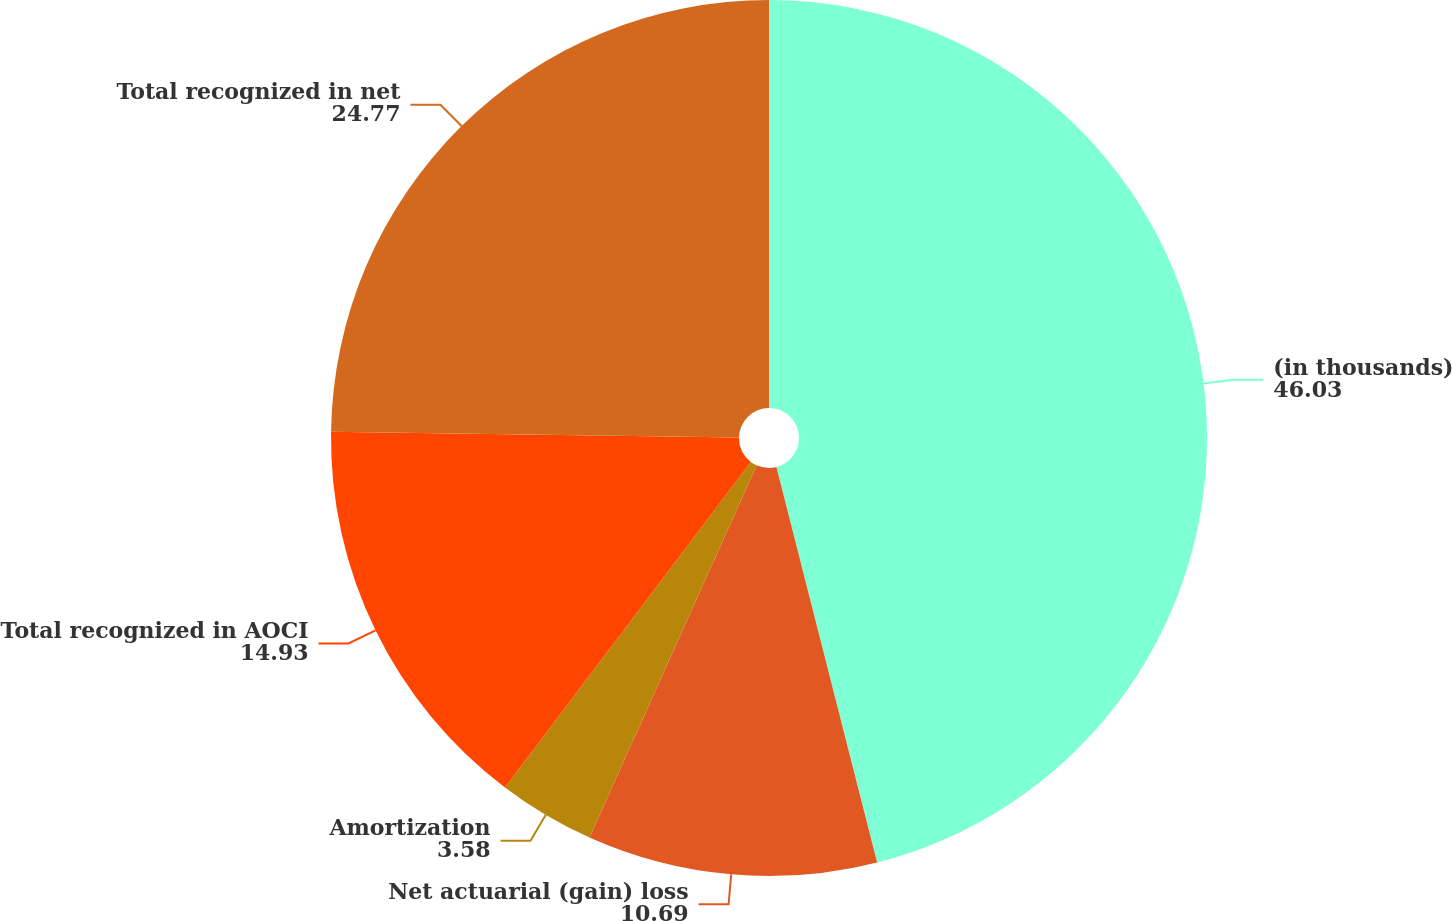Convert chart. <chart><loc_0><loc_0><loc_500><loc_500><pie_chart><fcel>(in thousands)<fcel>Net actuarial (gain) loss<fcel>Amortization<fcel>Total recognized in AOCI<fcel>Total recognized in net<nl><fcel>46.03%<fcel>10.69%<fcel>3.58%<fcel>14.93%<fcel>24.77%<nl></chart> 